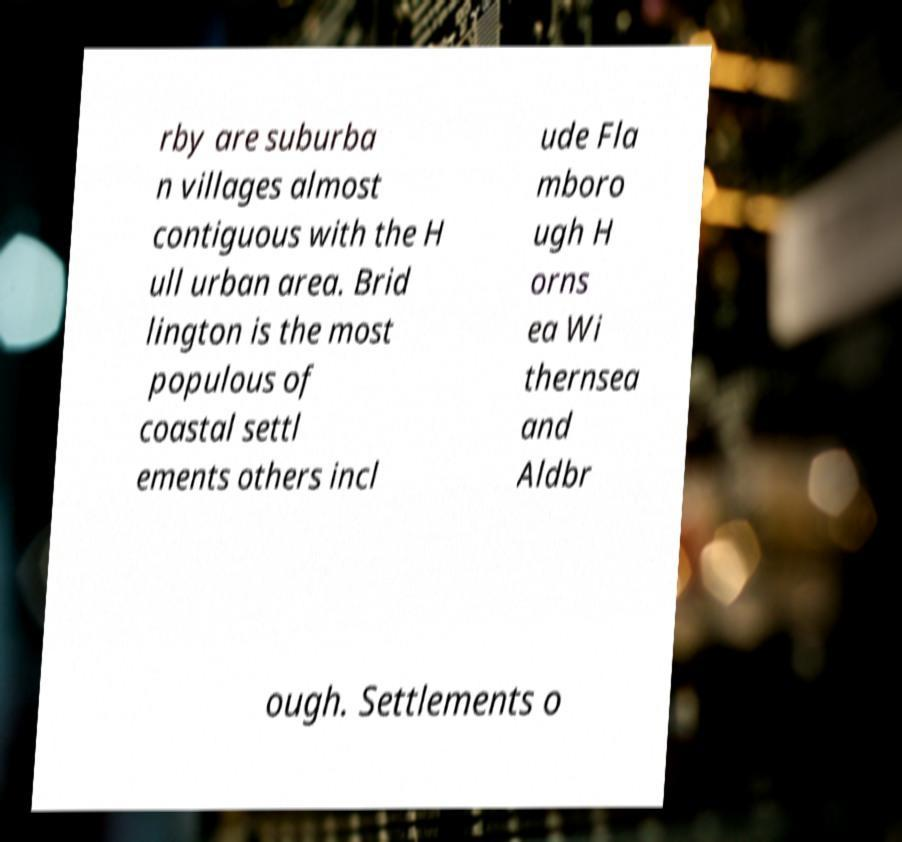Could you extract and type out the text from this image? rby are suburba n villages almost contiguous with the H ull urban area. Brid lington is the most populous of coastal settl ements others incl ude Fla mboro ugh H orns ea Wi thernsea and Aldbr ough. Settlements o 